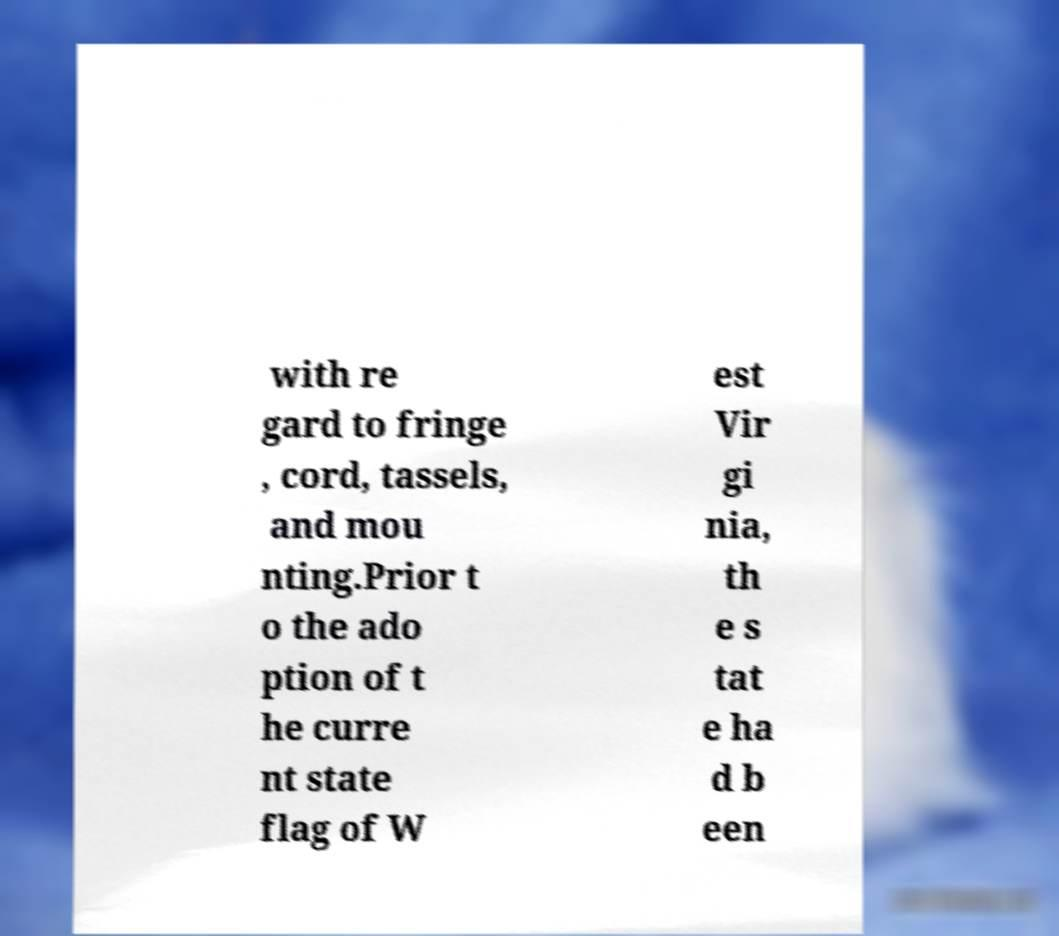Please identify and transcribe the text found in this image. with re gard to fringe , cord, tassels, and mou nting.Prior t o the ado ption of t he curre nt state flag of W est Vir gi nia, th e s tat e ha d b een 